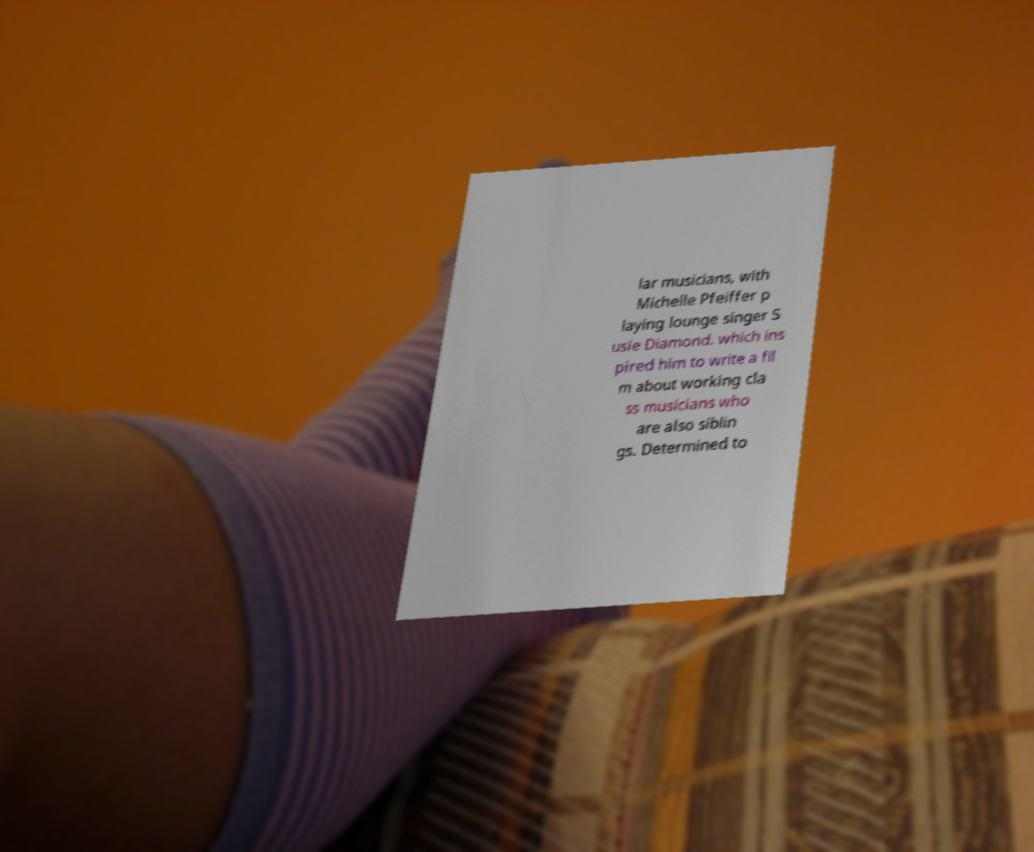What messages or text are displayed in this image? I need them in a readable, typed format. lar musicians, with Michelle Pfeiffer p laying lounge singer S usie Diamond. which ins pired him to write a fil m about working cla ss musicians who are also siblin gs. Determined to 